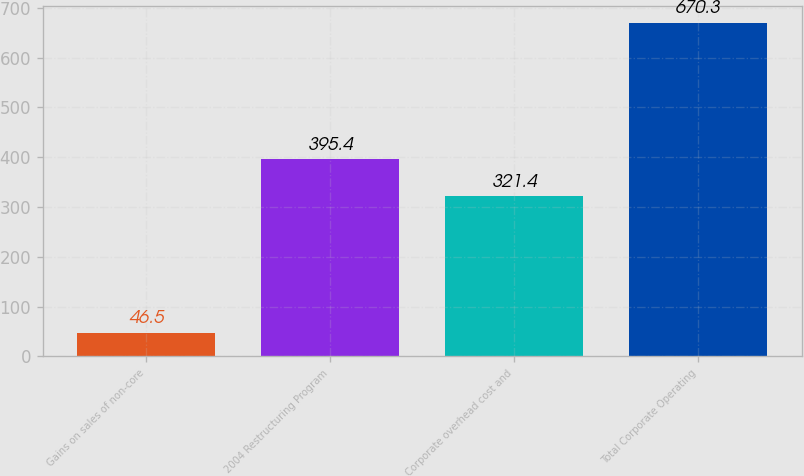Convert chart. <chart><loc_0><loc_0><loc_500><loc_500><bar_chart><fcel>Gains on sales of non-core<fcel>2004 Restructuring Program<fcel>Corporate overhead cost and<fcel>Total Corporate Operating<nl><fcel>46.5<fcel>395.4<fcel>321.4<fcel>670.3<nl></chart> 